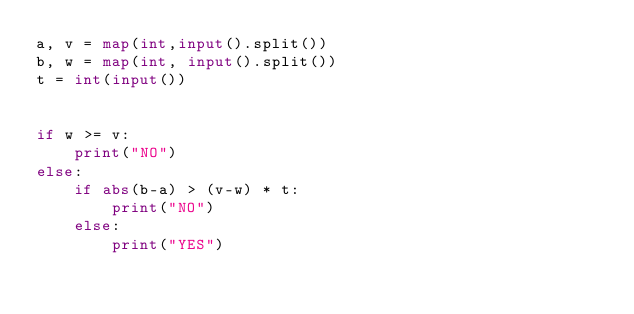Convert code to text. <code><loc_0><loc_0><loc_500><loc_500><_Python_>a, v = map(int,input().split())
b, w = map(int, input().split())
t = int(input())


if w >= v:
    print("NO")
else:
    if abs(b-a) > (v-w) * t:
        print("NO")
    else:
        print("YES")</code> 